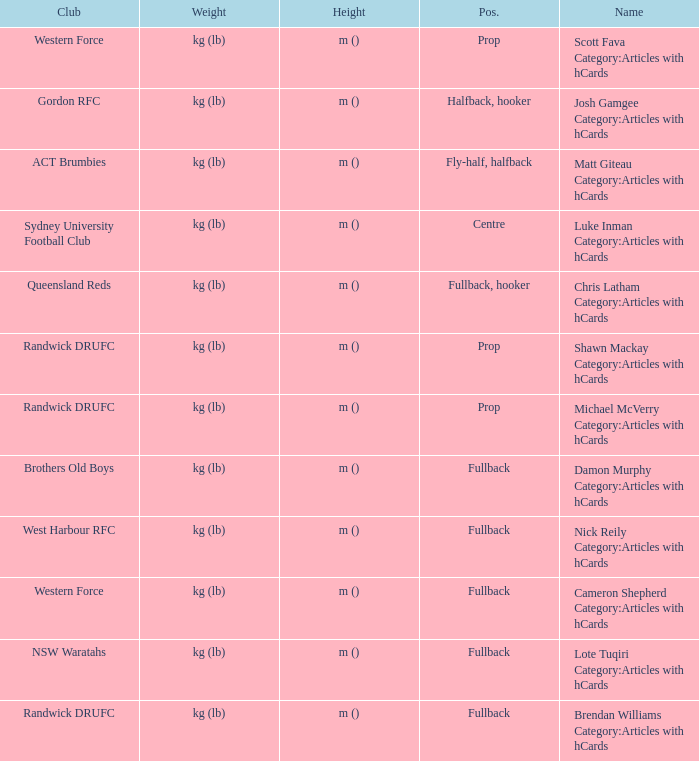What is the name when the position is centre? Luke Inman Category:Articles with hCards. 